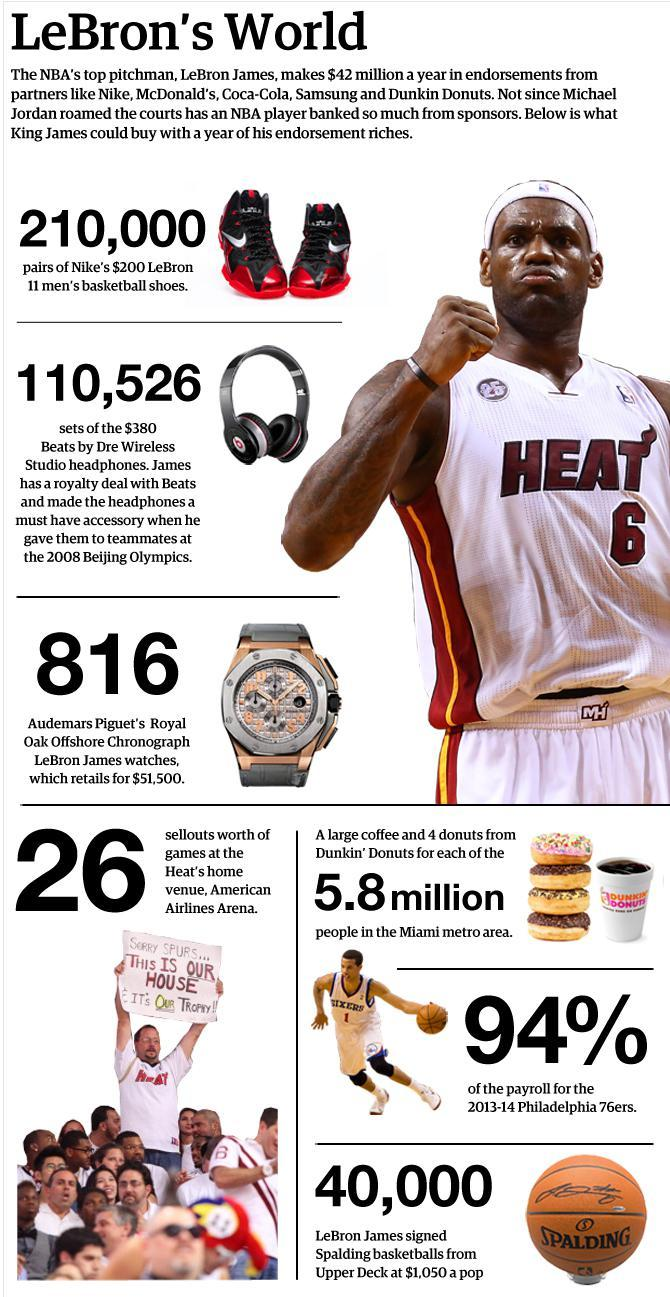Give some essential details in this illustration. There are two balls depicted in this infographic. 